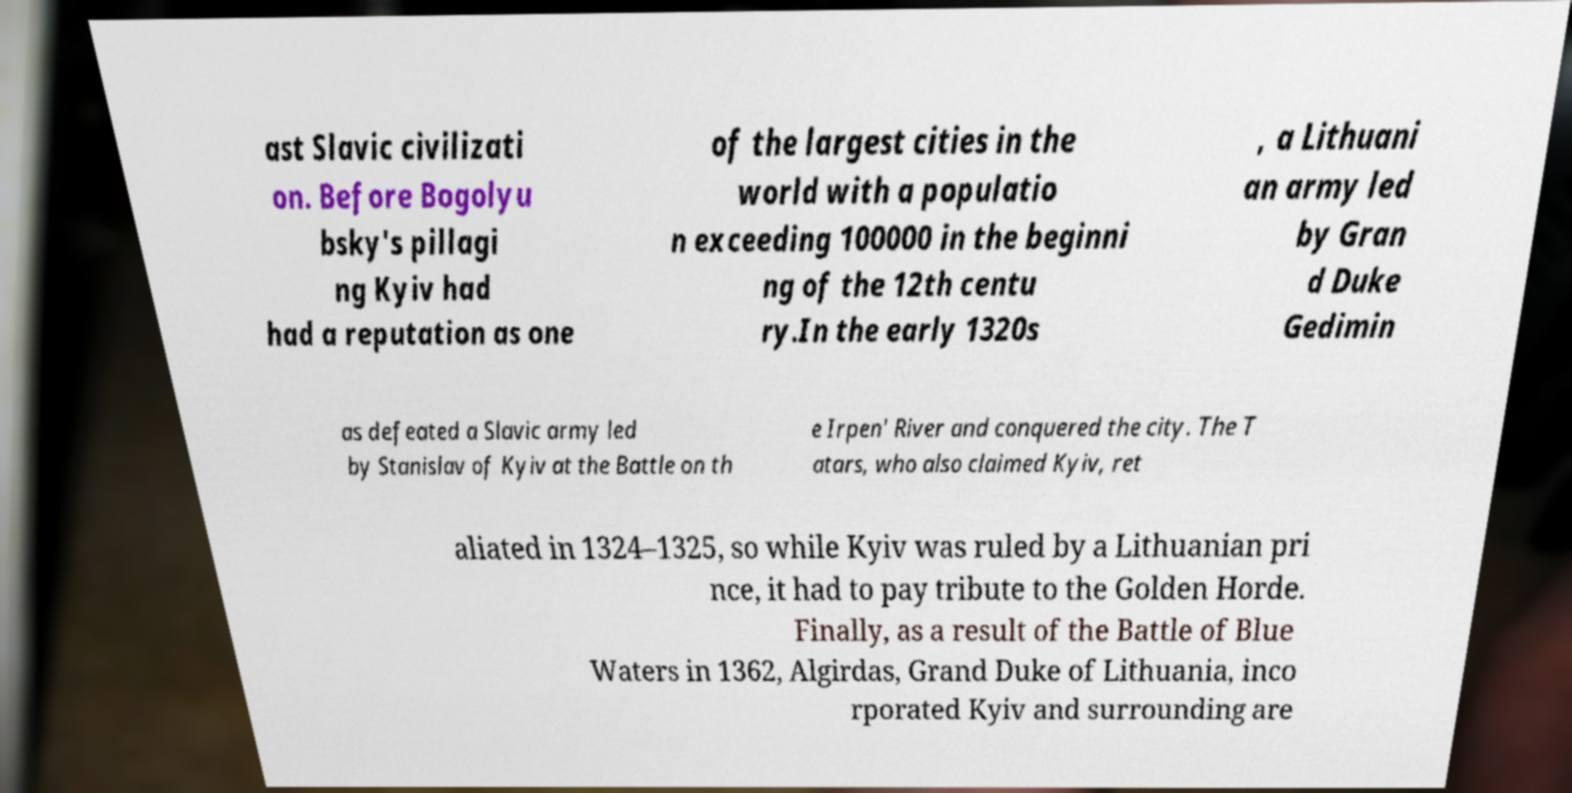What messages or text are displayed in this image? I need them in a readable, typed format. ast Slavic civilizati on. Before Bogolyu bsky's pillagi ng Kyiv had had a reputation as one of the largest cities in the world with a populatio n exceeding 100000 in the beginni ng of the 12th centu ry.In the early 1320s , a Lithuani an army led by Gran d Duke Gedimin as defeated a Slavic army led by Stanislav of Kyiv at the Battle on th e Irpen' River and conquered the city. The T atars, who also claimed Kyiv, ret aliated in 1324–1325, so while Kyiv was ruled by a Lithuanian pri nce, it had to pay tribute to the Golden Horde. Finally, as a result of the Battle of Blue Waters in 1362, Algirdas, Grand Duke of Lithuania, inco rporated Kyiv and surrounding are 